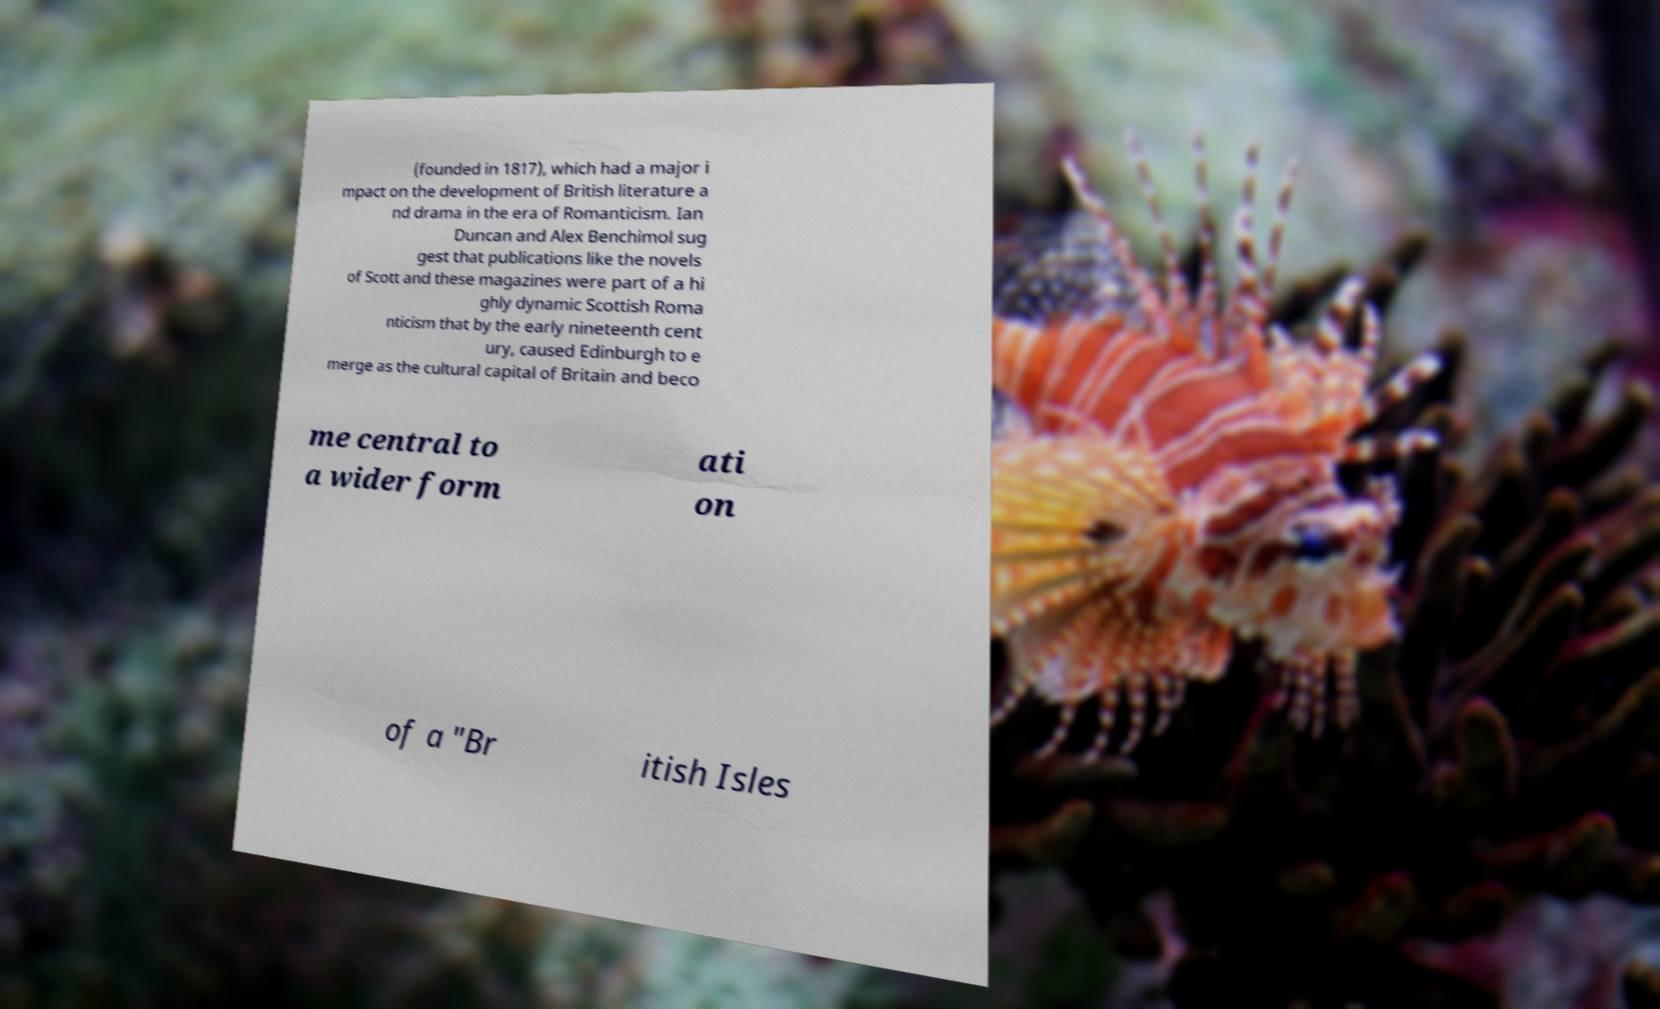Can you read and provide the text displayed in the image?This photo seems to have some interesting text. Can you extract and type it out for me? (founded in 1817), which had a major i mpact on the development of British literature a nd drama in the era of Romanticism. Ian Duncan and Alex Benchimol sug gest that publications like the novels of Scott and these magazines were part of a hi ghly dynamic Scottish Roma nticism that by the early nineteenth cent ury, caused Edinburgh to e merge as the cultural capital of Britain and beco me central to a wider form ati on of a "Br itish Isles 